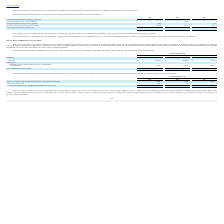From Ringcentral's financial document, What are the respective unrecognised tax benefits at the beginning of the year in 2017 and 2018? The document shows two values: $2,460 and $3,004 (in thousands). From the document: "benefits, beginning of the year $ 6,029 $ 3,004 $ 2,460 zed tax benefits, beginning of the year $ 6,029 $ 3,004 $ 2,460..." Also, What are the respective unrecognised tax benefits at the beginning of the year in 2018 and 2019? The document shows two values: $3,004 and $6,029 (in thousands). From the document: "nrecognized tax benefits, beginning of the year $ 6,029 $ 3,004 $ 2,460 zed tax benefits, beginning of the year $ 6,029 $ 3,004 $ 2,460..." Also, What are the respective increases related to current year tax positions in 2017 and 2018? The document shows two values: 547 and 1,975 (in thousands). From the document: "related to current year tax positions 2,984 1,975 547 eases related to current year tax positions 2,984 1,975 547..." Also, can you calculate: What is the percentage change in the unrecognized tax benefits, beginning of the year between 2017 and 2018? To answer this question, I need to perform calculations using the financial data. The calculation is: (3,004 - 2,460)/2,460 , which equals 22.11 (percentage). This is based on the information: "benefits, beginning of the year $ 6,029 $ 3,004 $ 2,460 zed tax benefits, beginning of the year $ 6,029 $ 3,004 $ 2,460..." The key data points involved are: 2,460, 3,004. Also, can you calculate: What is the percentage change in the unrecognized tax benefits at the beginning of the year between 2018 and 2019? To answer this question, I need to perform calculations using the financial data. The calculation is: (6,029 - 3,004)/3,004 , which equals 100.7 (percentage). This is based on the information: "nrecognized tax benefits, beginning of the year $ 6,029 $ 3,004 $ 2,460 zed tax benefits, beginning of the year $ 6,029 $ 3,004 $ 2,460..." The key data points involved are: 3,004, 6,029. Also, can you calculate: What is the average increases related to current year tax positions between 2017 to 2019? To answer this question, I need to perform calculations using the financial data. The calculation is: (2,984 + 1,975 + 547)/3 , which equals 1835.33 (in thousands). This is based on the information: "related to current year tax positions 2,984 1,975 547 Increases related to current year tax positions 2,984 1,975 547 eases related to current year tax positions 2,984 1,975 547..." The key data points involved are: 1,975, 2,984, 547. 